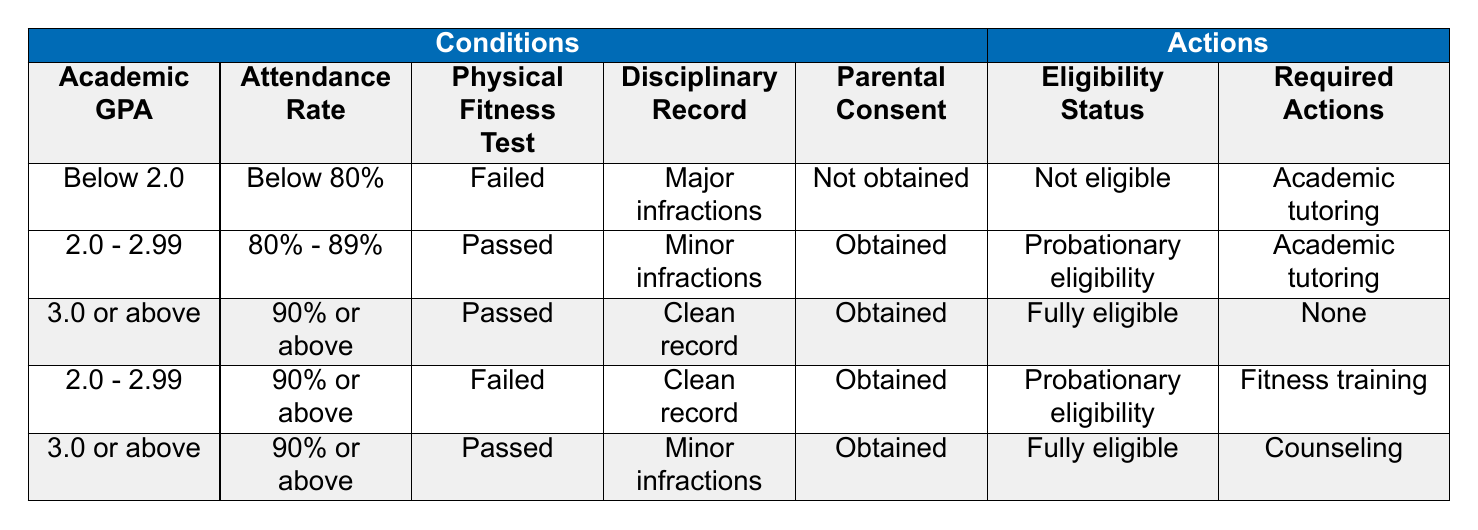What is the eligibility status for a student with a GPA below 2.0 and an attendance rate below 80%? According to the table, if a student has a GPA below 2.0 and an attendance rate below 80%, they fall under the first row of conditions. This row specifies that the eligibility status is "Not eligible."
Answer: Not eligible What actions are required for a student with a GPA between 2.0 and 2.99, an attendance rate between 80% and 89%, passed the physical fitness test, has minor infractions, and obtained parental consent? The second row outlines the eligibility status and required actions for the specified conditions. In this case, it indicates "Probationary eligibility" for eligibility status and "Academic tutoring" for required actions.
Answer: Academic tutoring Is a student with a GPA of 3.0 or above, 90% attendance, passed their physical fitness test, has a clean disciplinary record, and obtained parental consent fully eligible to participate in sports? The third row describes these exact conditions and confirms that the eligibility status is "Fully eligible." Thus, the student meets all the criteria to participate.
Answer: Yes How many different eligibility statuses are listed in the table? By examining the actions column, there are three unique eligibility statuses: "Not eligible," "Probationary eligibility," and "Fully eligible." Therefore, the total is three.
Answer: 3 If a student has a GPA of 2.0 to 2.99 and 90% or above attendance but failed their physical fitness test, what actions must they take? Referring to the fourth row, it indicates that such a student is labeled with "Probationary eligibility" and requires "Fitness training" as an action.
Answer: Fitness training Is there a condition where students are fully eligible but must receive counseling? The fifth row shows that students with a GPA of 3.0 or above, 90% or above attendance, passed their physical fitness test, have minor infractions, and obtained parental consent are fully eligible but must receive counseling. Therefore, the condition exists.
Answer: Yes What is the required action for a student with minor infractions and a GPA of 2.0 to 2.99 who has obtained parental consent and has an attendance rate between 80% - 89%? In this scenario, the second row is applicable. It indicates that the required action is "Academic tutoring."
Answer: Academic tutoring How would the eligibility status change for a student if their GPA improved from 2.0 - 2.99 to 3.0 or above, while maintaining the same attendance and fitness test results? According to the eligibility conditions, if the GPA increases to 3.0 or above, the student moves from "Probationary eligibility" (with a GPA below 3.0) to "Fully eligible," provided all other conditions remain the same. Thus, the eligibility status changes to fully eligible.
Answer: Yes, it changes to fully eligible 